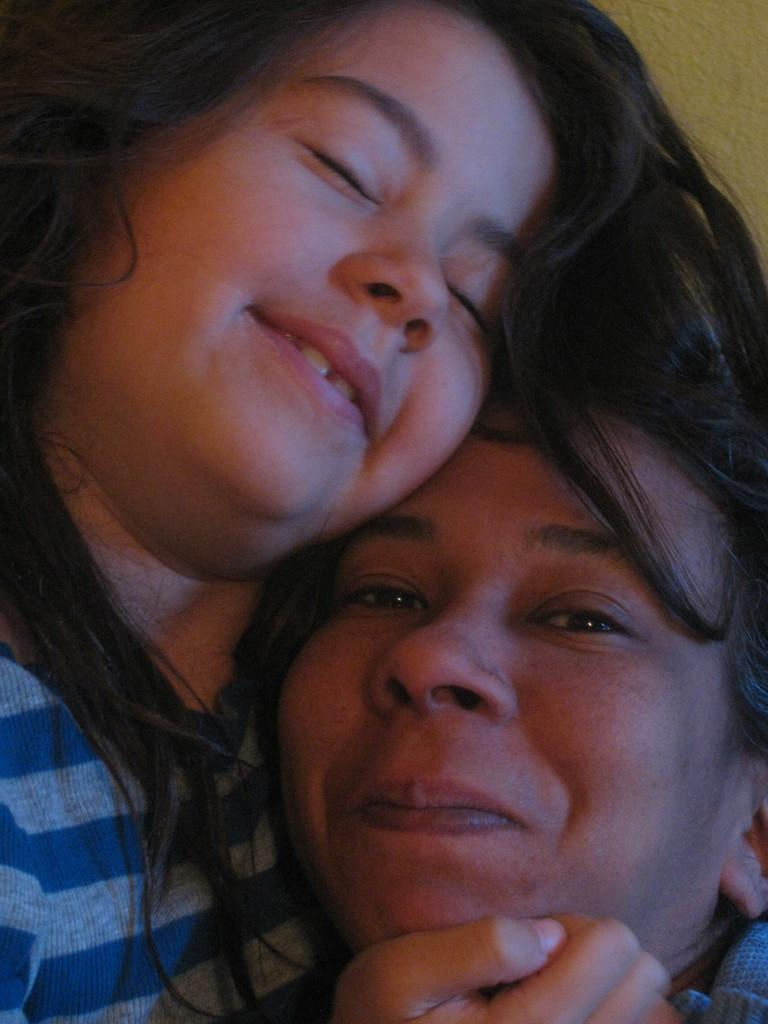What is on the left side of the image? There is a girl on the left side of the image. What is the girl wearing? The girl is wearing a t-shirt. What is the girl's facial expression? The girl is smiling. How is the girl interacting with the woman in the image? The girl has her hand under the cheek of the woman. What is the facial expression of the woman? The woman is smiling. What color is the background of the image? The background of the image is yellow in color. Can you tell me how many members are on the team in the image? There is no team present in the image; it features a girl and a woman interacting. What type of sea creature can be seen swimming in the background of the image? There is no sea creature visible in the image; the background is yellow in color. 